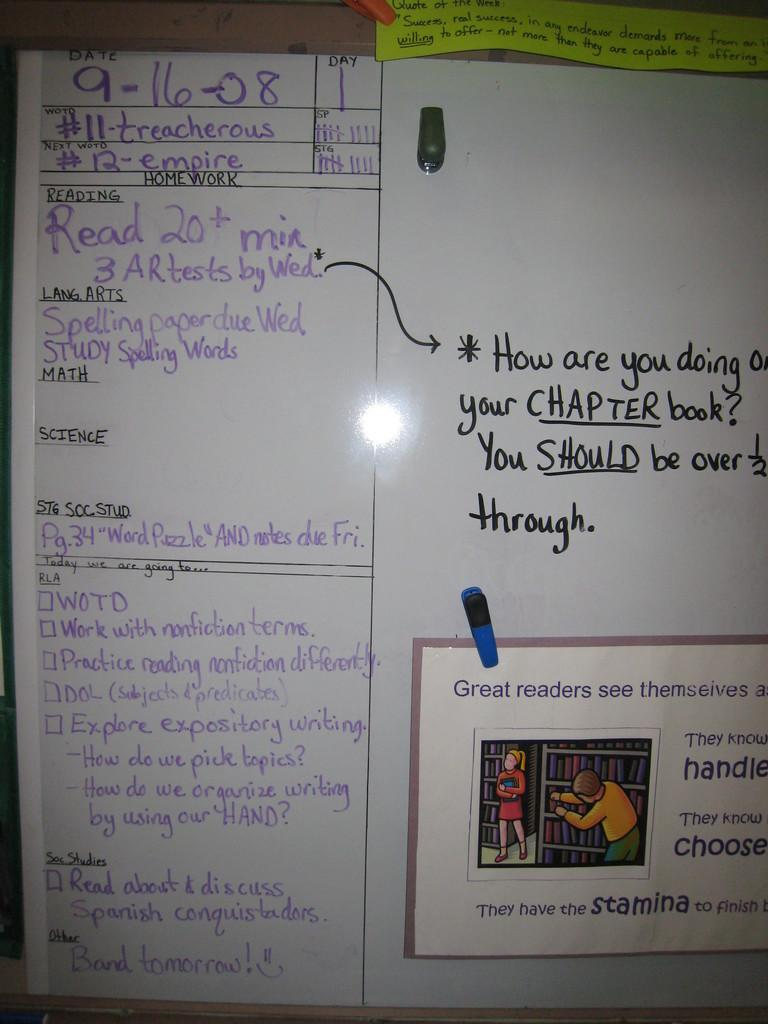<image>
Present a compact description of the photo's key features. A white board, dated 9-16-08, displays homework and other class agendas. 